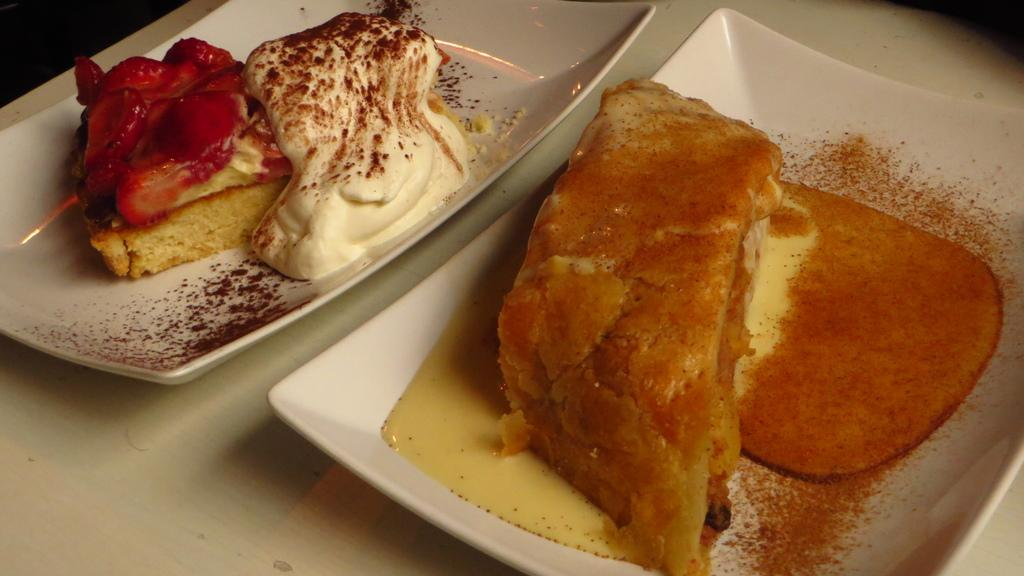What is present on the plates in the image? There is food on plates in the image. What is the cause of the butter's disappearance in the image? There is no butter mentioned in the image, so it cannot be determined what caused its disappearance. 